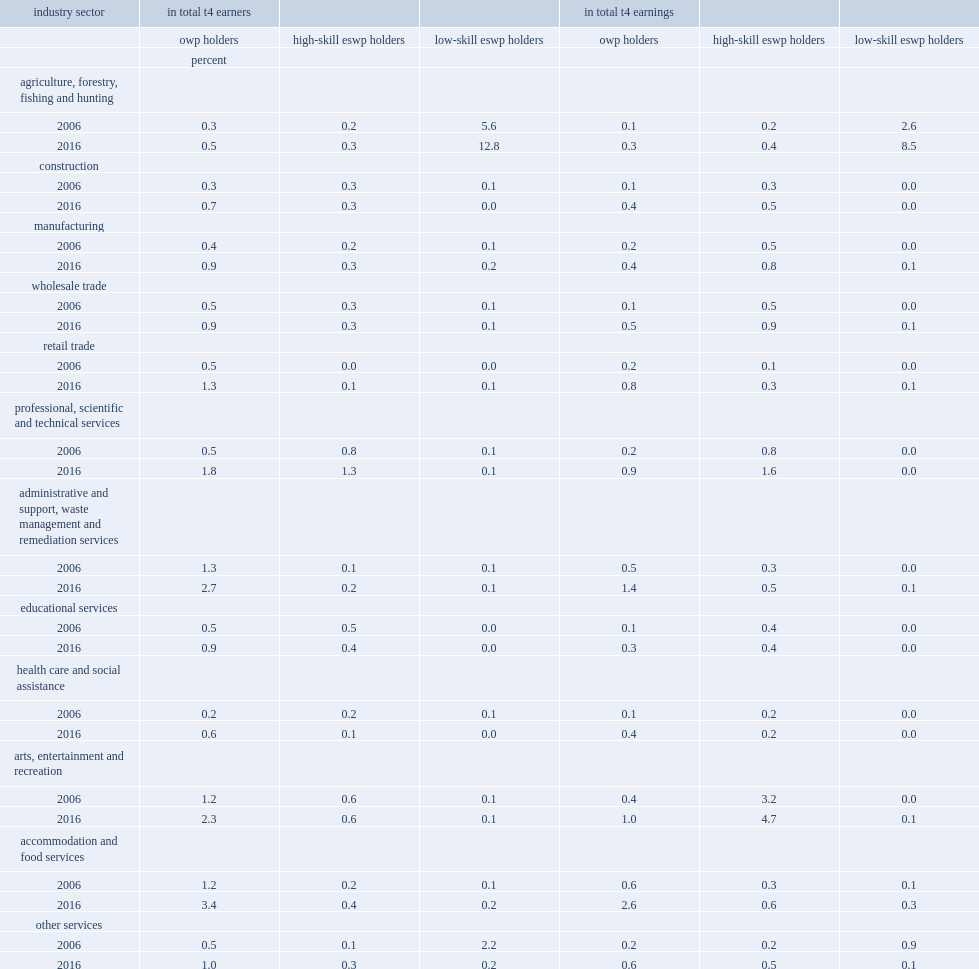What the percentage of the total t4 earners did owp holders account for in accommodation and food services in 2016? 3.4. What the percentage of the total t4 earnings did owp holders account for in accommodation and food services in 2016? 2.6. What the percentage of the total t4 earners did low-skill eswp holders account for in agriculture, forestry, fishing and hunting in 2016? 12.8. What the percentage of the total t4 earnings did low-skill eswp holders account for in agriculture, forestry, fishing and hunting in 2016? 8.5. 